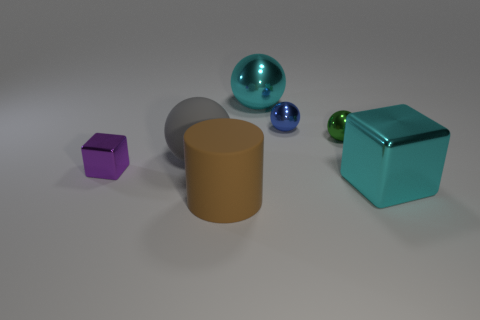Is the number of big rubber cylinders that are to the left of the large rubber cylinder greater than the number of big shiny blocks that are to the left of the large cyan cube?
Your answer should be compact. No. What color is the large sphere behind the big matte thing that is left of the cylinder?
Make the answer very short. Cyan. What number of cylinders are either blue things or big cyan things?
Give a very brief answer. 0. How many small objects are both on the right side of the tiny blue sphere and left of the big brown matte thing?
Give a very brief answer. 0. There is a shiny cube that is on the left side of the brown cylinder; what is its color?
Make the answer very short. Purple. What size is the blue thing that is the same material as the small purple object?
Your response must be concise. Small. What number of large cyan shiny things are to the right of the big cyan metal object behind the tiny cube?
Offer a very short reply. 1. What number of tiny metallic things are on the right side of the blue sphere?
Your answer should be compact. 1. There is a big ball on the left side of the large sphere that is to the right of the large matte thing in front of the tiny purple metallic block; what color is it?
Your response must be concise. Gray. Does the tiny object to the left of the brown matte cylinder have the same color as the big matte thing that is in front of the cyan metallic cube?
Provide a short and direct response. No. 